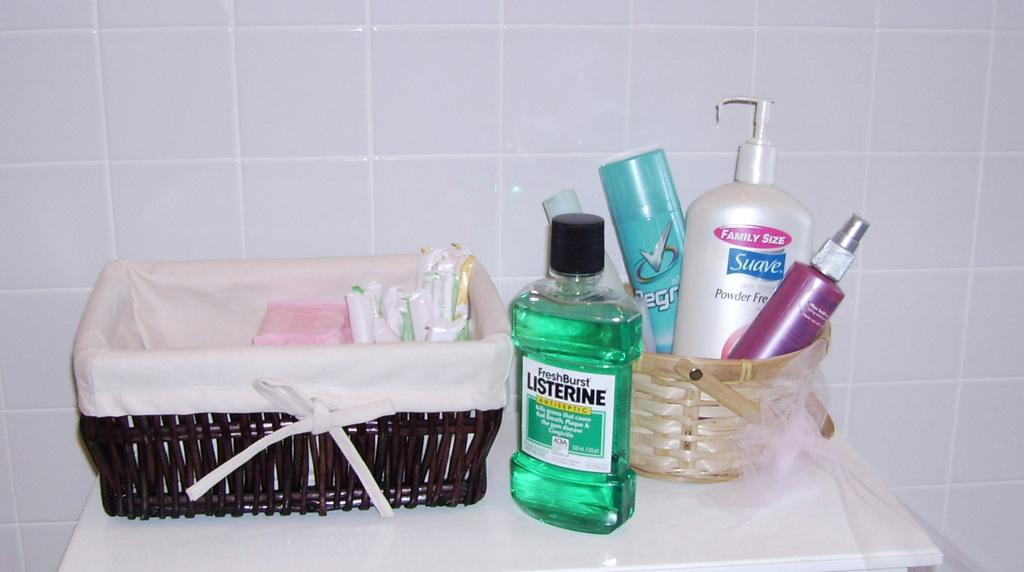What objects are on the table in the image? There are bottles and baskets on a table in the image. What can be seen behind the table in the image? There is a wall in the image. How many bananas are in the baskets on the table in the image? There is no information about bananas in the image; only bottles and baskets are mentioned. 